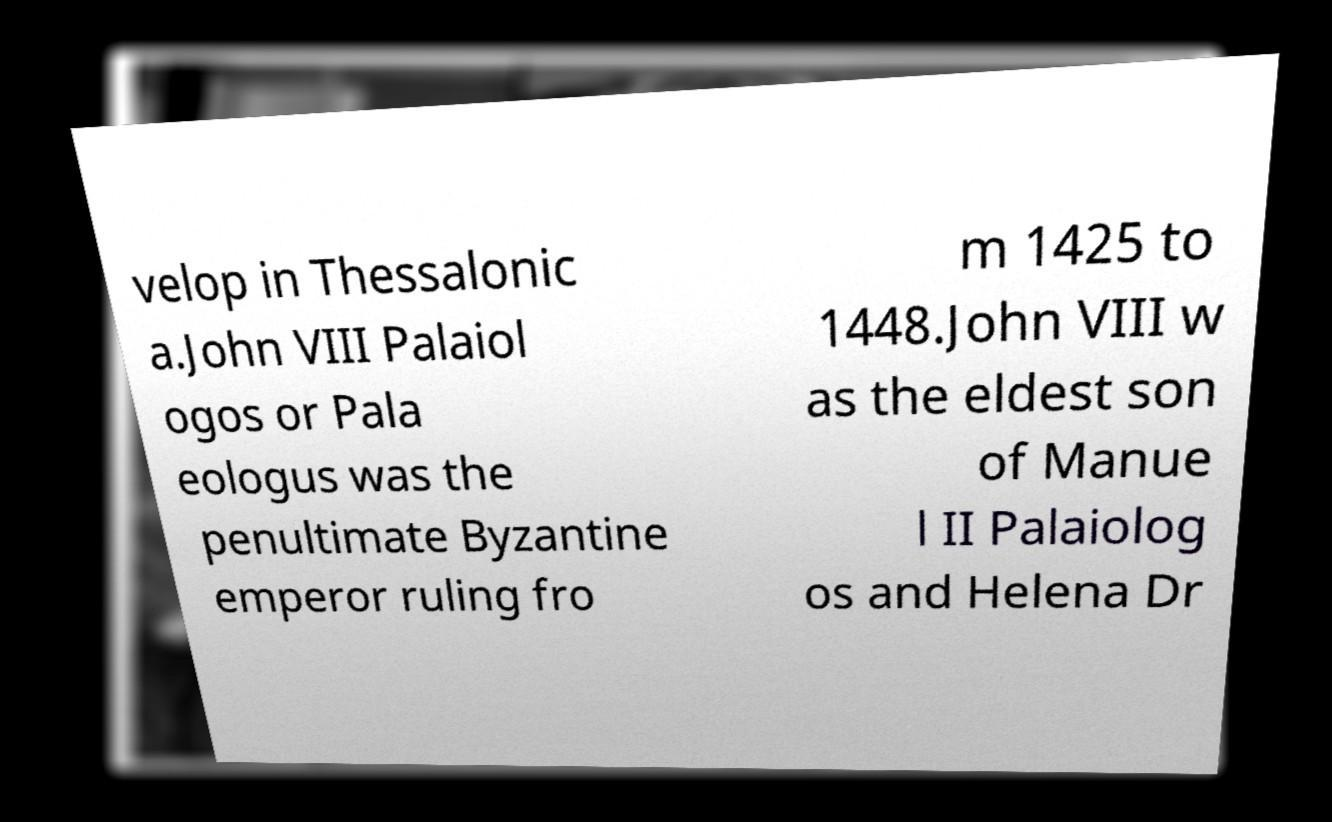What messages or text are displayed in this image? I need them in a readable, typed format. velop in Thessalonic a.John VIII Palaiol ogos or Pala eologus was the penultimate Byzantine emperor ruling fro m 1425 to 1448.John VIII w as the eldest son of Manue l II Palaiolog os and Helena Dr 